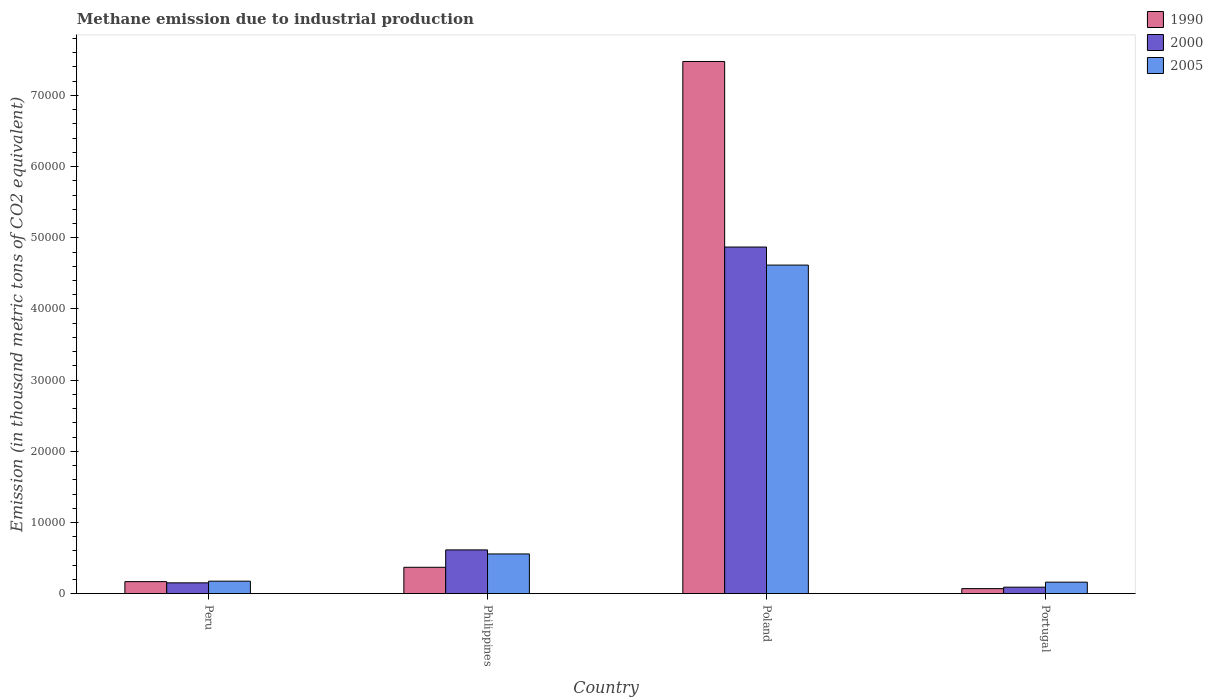How many different coloured bars are there?
Offer a terse response. 3. How many groups of bars are there?
Offer a very short reply. 4. Are the number of bars on each tick of the X-axis equal?
Your response must be concise. Yes. What is the label of the 3rd group of bars from the left?
Make the answer very short. Poland. What is the amount of methane emitted in 2005 in Portugal?
Offer a very short reply. 1615. Across all countries, what is the maximum amount of methane emitted in 2005?
Offer a very short reply. 4.62e+04. Across all countries, what is the minimum amount of methane emitted in 1990?
Offer a very short reply. 708.7. In which country was the amount of methane emitted in 1990 maximum?
Keep it short and to the point. Poland. What is the total amount of methane emitted in 2005 in the graph?
Make the answer very short. 5.51e+04. What is the difference between the amount of methane emitted in 2000 in Poland and that in Portugal?
Give a very brief answer. 4.78e+04. What is the difference between the amount of methane emitted in 2000 in Philippines and the amount of methane emitted in 1990 in Poland?
Keep it short and to the point. -6.86e+04. What is the average amount of methane emitted in 2000 per country?
Give a very brief answer. 1.43e+04. What is the difference between the amount of methane emitted of/in 2005 and amount of methane emitted of/in 2000 in Philippines?
Ensure brevity in your answer.  -568.2. What is the ratio of the amount of methane emitted in 2000 in Peru to that in Philippines?
Your answer should be compact. 0.25. What is the difference between the highest and the second highest amount of methane emitted in 2005?
Provide a succinct answer. -3827.8. What is the difference between the highest and the lowest amount of methane emitted in 1990?
Your response must be concise. 7.41e+04. What does the 3rd bar from the right in Philippines represents?
Your response must be concise. 1990. How many bars are there?
Your answer should be compact. 12. Are all the bars in the graph horizontal?
Keep it short and to the point. No. What is the difference between two consecutive major ticks on the Y-axis?
Keep it short and to the point. 10000. Are the values on the major ticks of Y-axis written in scientific E-notation?
Provide a short and direct response. No. What is the title of the graph?
Provide a succinct answer. Methane emission due to industrial production. What is the label or title of the X-axis?
Offer a very short reply. Country. What is the label or title of the Y-axis?
Offer a very short reply. Emission (in thousand metric tons of CO2 equivalent). What is the Emission (in thousand metric tons of CO2 equivalent) of 1990 in Peru?
Ensure brevity in your answer.  1689.8. What is the Emission (in thousand metric tons of CO2 equivalent) in 2000 in Peru?
Offer a very short reply. 1520.5. What is the Emission (in thousand metric tons of CO2 equivalent) of 2005 in Peru?
Give a very brief answer. 1753.1. What is the Emission (in thousand metric tons of CO2 equivalent) of 1990 in Philippines?
Your answer should be very brief. 3704.2. What is the Emission (in thousand metric tons of CO2 equivalent) in 2000 in Philippines?
Provide a short and direct response. 6149.1. What is the Emission (in thousand metric tons of CO2 equivalent) of 2005 in Philippines?
Offer a terse response. 5580.9. What is the Emission (in thousand metric tons of CO2 equivalent) of 1990 in Poland?
Give a very brief answer. 7.48e+04. What is the Emission (in thousand metric tons of CO2 equivalent) of 2000 in Poland?
Keep it short and to the point. 4.87e+04. What is the Emission (in thousand metric tons of CO2 equivalent) of 2005 in Poland?
Offer a very short reply. 4.62e+04. What is the Emission (in thousand metric tons of CO2 equivalent) in 1990 in Portugal?
Provide a succinct answer. 708.7. What is the Emission (in thousand metric tons of CO2 equivalent) in 2000 in Portugal?
Give a very brief answer. 909.6. What is the Emission (in thousand metric tons of CO2 equivalent) in 2005 in Portugal?
Provide a succinct answer. 1615. Across all countries, what is the maximum Emission (in thousand metric tons of CO2 equivalent) of 1990?
Provide a short and direct response. 7.48e+04. Across all countries, what is the maximum Emission (in thousand metric tons of CO2 equivalent) of 2000?
Provide a succinct answer. 4.87e+04. Across all countries, what is the maximum Emission (in thousand metric tons of CO2 equivalent) of 2005?
Keep it short and to the point. 4.62e+04. Across all countries, what is the minimum Emission (in thousand metric tons of CO2 equivalent) in 1990?
Your answer should be compact. 708.7. Across all countries, what is the minimum Emission (in thousand metric tons of CO2 equivalent) of 2000?
Give a very brief answer. 909.6. Across all countries, what is the minimum Emission (in thousand metric tons of CO2 equivalent) of 2005?
Your response must be concise. 1615. What is the total Emission (in thousand metric tons of CO2 equivalent) of 1990 in the graph?
Make the answer very short. 8.09e+04. What is the total Emission (in thousand metric tons of CO2 equivalent) of 2000 in the graph?
Make the answer very short. 5.73e+04. What is the total Emission (in thousand metric tons of CO2 equivalent) in 2005 in the graph?
Give a very brief answer. 5.51e+04. What is the difference between the Emission (in thousand metric tons of CO2 equivalent) in 1990 in Peru and that in Philippines?
Your answer should be very brief. -2014.4. What is the difference between the Emission (in thousand metric tons of CO2 equivalent) of 2000 in Peru and that in Philippines?
Keep it short and to the point. -4628.6. What is the difference between the Emission (in thousand metric tons of CO2 equivalent) in 2005 in Peru and that in Philippines?
Your answer should be compact. -3827.8. What is the difference between the Emission (in thousand metric tons of CO2 equivalent) of 1990 in Peru and that in Poland?
Provide a short and direct response. -7.31e+04. What is the difference between the Emission (in thousand metric tons of CO2 equivalent) in 2000 in Peru and that in Poland?
Provide a short and direct response. -4.72e+04. What is the difference between the Emission (in thousand metric tons of CO2 equivalent) in 2005 in Peru and that in Poland?
Provide a short and direct response. -4.44e+04. What is the difference between the Emission (in thousand metric tons of CO2 equivalent) in 1990 in Peru and that in Portugal?
Keep it short and to the point. 981.1. What is the difference between the Emission (in thousand metric tons of CO2 equivalent) of 2000 in Peru and that in Portugal?
Your answer should be compact. 610.9. What is the difference between the Emission (in thousand metric tons of CO2 equivalent) of 2005 in Peru and that in Portugal?
Give a very brief answer. 138.1. What is the difference between the Emission (in thousand metric tons of CO2 equivalent) in 1990 in Philippines and that in Poland?
Make the answer very short. -7.11e+04. What is the difference between the Emission (in thousand metric tons of CO2 equivalent) of 2000 in Philippines and that in Poland?
Offer a very short reply. -4.26e+04. What is the difference between the Emission (in thousand metric tons of CO2 equivalent) in 2005 in Philippines and that in Poland?
Ensure brevity in your answer.  -4.06e+04. What is the difference between the Emission (in thousand metric tons of CO2 equivalent) of 1990 in Philippines and that in Portugal?
Offer a terse response. 2995.5. What is the difference between the Emission (in thousand metric tons of CO2 equivalent) in 2000 in Philippines and that in Portugal?
Your response must be concise. 5239.5. What is the difference between the Emission (in thousand metric tons of CO2 equivalent) in 2005 in Philippines and that in Portugal?
Keep it short and to the point. 3965.9. What is the difference between the Emission (in thousand metric tons of CO2 equivalent) in 1990 in Poland and that in Portugal?
Make the answer very short. 7.41e+04. What is the difference between the Emission (in thousand metric tons of CO2 equivalent) of 2000 in Poland and that in Portugal?
Your response must be concise. 4.78e+04. What is the difference between the Emission (in thousand metric tons of CO2 equivalent) of 2005 in Poland and that in Portugal?
Make the answer very short. 4.45e+04. What is the difference between the Emission (in thousand metric tons of CO2 equivalent) of 1990 in Peru and the Emission (in thousand metric tons of CO2 equivalent) of 2000 in Philippines?
Keep it short and to the point. -4459.3. What is the difference between the Emission (in thousand metric tons of CO2 equivalent) in 1990 in Peru and the Emission (in thousand metric tons of CO2 equivalent) in 2005 in Philippines?
Your answer should be compact. -3891.1. What is the difference between the Emission (in thousand metric tons of CO2 equivalent) in 2000 in Peru and the Emission (in thousand metric tons of CO2 equivalent) in 2005 in Philippines?
Give a very brief answer. -4060.4. What is the difference between the Emission (in thousand metric tons of CO2 equivalent) in 1990 in Peru and the Emission (in thousand metric tons of CO2 equivalent) in 2000 in Poland?
Ensure brevity in your answer.  -4.70e+04. What is the difference between the Emission (in thousand metric tons of CO2 equivalent) of 1990 in Peru and the Emission (in thousand metric tons of CO2 equivalent) of 2005 in Poland?
Ensure brevity in your answer.  -4.45e+04. What is the difference between the Emission (in thousand metric tons of CO2 equivalent) of 2000 in Peru and the Emission (in thousand metric tons of CO2 equivalent) of 2005 in Poland?
Offer a terse response. -4.46e+04. What is the difference between the Emission (in thousand metric tons of CO2 equivalent) of 1990 in Peru and the Emission (in thousand metric tons of CO2 equivalent) of 2000 in Portugal?
Offer a terse response. 780.2. What is the difference between the Emission (in thousand metric tons of CO2 equivalent) in 1990 in Peru and the Emission (in thousand metric tons of CO2 equivalent) in 2005 in Portugal?
Make the answer very short. 74.8. What is the difference between the Emission (in thousand metric tons of CO2 equivalent) of 2000 in Peru and the Emission (in thousand metric tons of CO2 equivalent) of 2005 in Portugal?
Your answer should be very brief. -94.5. What is the difference between the Emission (in thousand metric tons of CO2 equivalent) of 1990 in Philippines and the Emission (in thousand metric tons of CO2 equivalent) of 2000 in Poland?
Make the answer very short. -4.50e+04. What is the difference between the Emission (in thousand metric tons of CO2 equivalent) in 1990 in Philippines and the Emission (in thousand metric tons of CO2 equivalent) in 2005 in Poland?
Your answer should be very brief. -4.25e+04. What is the difference between the Emission (in thousand metric tons of CO2 equivalent) in 2000 in Philippines and the Emission (in thousand metric tons of CO2 equivalent) in 2005 in Poland?
Your answer should be very brief. -4.00e+04. What is the difference between the Emission (in thousand metric tons of CO2 equivalent) of 1990 in Philippines and the Emission (in thousand metric tons of CO2 equivalent) of 2000 in Portugal?
Your response must be concise. 2794.6. What is the difference between the Emission (in thousand metric tons of CO2 equivalent) of 1990 in Philippines and the Emission (in thousand metric tons of CO2 equivalent) of 2005 in Portugal?
Offer a very short reply. 2089.2. What is the difference between the Emission (in thousand metric tons of CO2 equivalent) of 2000 in Philippines and the Emission (in thousand metric tons of CO2 equivalent) of 2005 in Portugal?
Provide a short and direct response. 4534.1. What is the difference between the Emission (in thousand metric tons of CO2 equivalent) in 1990 in Poland and the Emission (in thousand metric tons of CO2 equivalent) in 2000 in Portugal?
Ensure brevity in your answer.  7.39e+04. What is the difference between the Emission (in thousand metric tons of CO2 equivalent) in 1990 in Poland and the Emission (in thousand metric tons of CO2 equivalent) in 2005 in Portugal?
Provide a succinct answer. 7.32e+04. What is the difference between the Emission (in thousand metric tons of CO2 equivalent) in 2000 in Poland and the Emission (in thousand metric tons of CO2 equivalent) in 2005 in Portugal?
Provide a short and direct response. 4.71e+04. What is the average Emission (in thousand metric tons of CO2 equivalent) of 1990 per country?
Your response must be concise. 2.02e+04. What is the average Emission (in thousand metric tons of CO2 equivalent) of 2000 per country?
Ensure brevity in your answer.  1.43e+04. What is the average Emission (in thousand metric tons of CO2 equivalent) of 2005 per country?
Give a very brief answer. 1.38e+04. What is the difference between the Emission (in thousand metric tons of CO2 equivalent) in 1990 and Emission (in thousand metric tons of CO2 equivalent) in 2000 in Peru?
Make the answer very short. 169.3. What is the difference between the Emission (in thousand metric tons of CO2 equivalent) of 1990 and Emission (in thousand metric tons of CO2 equivalent) of 2005 in Peru?
Your answer should be very brief. -63.3. What is the difference between the Emission (in thousand metric tons of CO2 equivalent) of 2000 and Emission (in thousand metric tons of CO2 equivalent) of 2005 in Peru?
Your answer should be very brief. -232.6. What is the difference between the Emission (in thousand metric tons of CO2 equivalent) in 1990 and Emission (in thousand metric tons of CO2 equivalent) in 2000 in Philippines?
Ensure brevity in your answer.  -2444.9. What is the difference between the Emission (in thousand metric tons of CO2 equivalent) of 1990 and Emission (in thousand metric tons of CO2 equivalent) of 2005 in Philippines?
Provide a succinct answer. -1876.7. What is the difference between the Emission (in thousand metric tons of CO2 equivalent) of 2000 and Emission (in thousand metric tons of CO2 equivalent) of 2005 in Philippines?
Provide a succinct answer. 568.2. What is the difference between the Emission (in thousand metric tons of CO2 equivalent) of 1990 and Emission (in thousand metric tons of CO2 equivalent) of 2000 in Poland?
Provide a short and direct response. 2.61e+04. What is the difference between the Emission (in thousand metric tons of CO2 equivalent) in 1990 and Emission (in thousand metric tons of CO2 equivalent) in 2005 in Poland?
Keep it short and to the point. 2.86e+04. What is the difference between the Emission (in thousand metric tons of CO2 equivalent) of 2000 and Emission (in thousand metric tons of CO2 equivalent) of 2005 in Poland?
Offer a terse response. 2536.5. What is the difference between the Emission (in thousand metric tons of CO2 equivalent) in 1990 and Emission (in thousand metric tons of CO2 equivalent) in 2000 in Portugal?
Offer a very short reply. -200.9. What is the difference between the Emission (in thousand metric tons of CO2 equivalent) in 1990 and Emission (in thousand metric tons of CO2 equivalent) in 2005 in Portugal?
Keep it short and to the point. -906.3. What is the difference between the Emission (in thousand metric tons of CO2 equivalent) of 2000 and Emission (in thousand metric tons of CO2 equivalent) of 2005 in Portugal?
Offer a very short reply. -705.4. What is the ratio of the Emission (in thousand metric tons of CO2 equivalent) in 1990 in Peru to that in Philippines?
Offer a terse response. 0.46. What is the ratio of the Emission (in thousand metric tons of CO2 equivalent) of 2000 in Peru to that in Philippines?
Provide a succinct answer. 0.25. What is the ratio of the Emission (in thousand metric tons of CO2 equivalent) in 2005 in Peru to that in Philippines?
Your response must be concise. 0.31. What is the ratio of the Emission (in thousand metric tons of CO2 equivalent) of 1990 in Peru to that in Poland?
Your answer should be very brief. 0.02. What is the ratio of the Emission (in thousand metric tons of CO2 equivalent) in 2000 in Peru to that in Poland?
Give a very brief answer. 0.03. What is the ratio of the Emission (in thousand metric tons of CO2 equivalent) of 2005 in Peru to that in Poland?
Provide a short and direct response. 0.04. What is the ratio of the Emission (in thousand metric tons of CO2 equivalent) of 1990 in Peru to that in Portugal?
Keep it short and to the point. 2.38. What is the ratio of the Emission (in thousand metric tons of CO2 equivalent) of 2000 in Peru to that in Portugal?
Provide a short and direct response. 1.67. What is the ratio of the Emission (in thousand metric tons of CO2 equivalent) of 2005 in Peru to that in Portugal?
Make the answer very short. 1.09. What is the ratio of the Emission (in thousand metric tons of CO2 equivalent) in 1990 in Philippines to that in Poland?
Offer a terse response. 0.05. What is the ratio of the Emission (in thousand metric tons of CO2 equivalent) of 2000 in Philippines to that in Poland?
Make the answer very short. 0.13. What is the ratio of the Emission (in thousand metric tons of CO2 equivalent) of 2005 in Philippines to that in Poland?
Offer a terse response. 0.12. What is the ratio of the Emission (in thousand metric tons of CO2 equivalent) in 1990 in Philippines to that in Portugal?
Offer a terse response. 5.23. What is the ratio of the Emission (in thousand metric tons of CO2 equivalent) of 2000 in Philippines to that in Portugal?
Make the answer very short. 6.76. What is the ratio of the Emission (in thousand metric tons of CO2 equivalent) in 2005 in Philippines to that in Portugal?
Your response must be concise. 3.46. What is the ratio of the Emission (in thousand metric tons of CO2 equivalent) in 1990 in Poland to that in Portugal?
Ensure brevity in your answer.  105.51. What is the ratio of the Emission (in thousand metric tons of CO2 equivalent) in 2000 in Poland to that in Portugal?
Ensure brevity in your answer.  53.54. What is the ratio of the Emission (in thousand metric tons of CO2 equivalent) in 2005 in Poland to that in Portugal?
Your answer should be compact. 28.58. What is the difference between the highest and the second highest Emission (in thousand metric tons of CO2 equivalent) in 1990?
Your answer should be very brief. 7.11e+04. What is the difference between the highest and the second highest Emission (in thousand metric tons of CO2 equivalent) in 2000?
Your answer should be compact. 4.26e+04. What is the difference between the highest and the second highest Emission (in thousand metric tons of CO2 equivalent) in 2005?
Provide a short and direct response. 4.06e+04. What is the difference between the highest and the lowest Emission (in thousand metric tons of CO2 equivalent) in 1990?
Give a very brief answer. 7.41e+04. What is the difference between the highest and the lowest Emission (in thousand metric tons of CO2 equivalent) of 2000?
Your response must be concise. 4.78e+04. What is the difference between the highest and the lowest Emission (in thousand metric tons of CO2 equivalent) of 2005?
Your answer should be compact. 4.45e+04. 